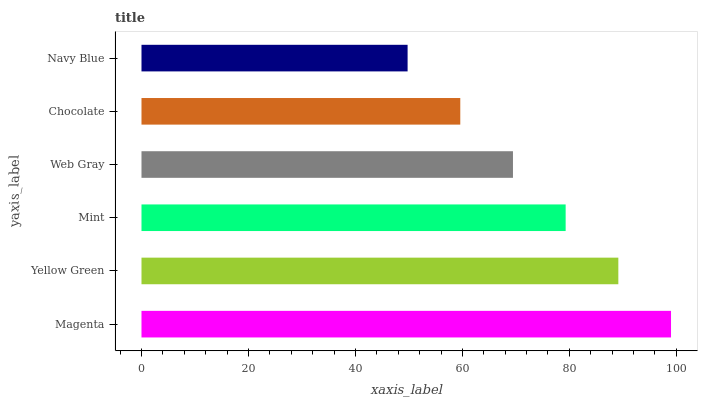Is Navy Blue the minimum?
Answer yes or no. Yes. Is Magenta the maximum?
Answer yes or no. Yes. Is Yellow Green the minimum?
Answer yes or no. No. Is Yellow Green the maximum?
Answer yes or no. No. Is Magenta greater than Yellow Green?
Answer yes or no. Yes. Is Yellow Green less than Magenta?
Answer yes or no. Yes. Is Yellow Green greater than Magenta?
Answer yes or no. No. Is Magenta less than Yellow Green?
Answer yes or no. No. Is Mint the high median?
Answer yes or no. Yes. Is Web Gray the low median?
Answer yes or no. Yes. Is Chocolate the high median?
Answer yes or no. No. Is Mint the low median?
Answer yes or no. No. 